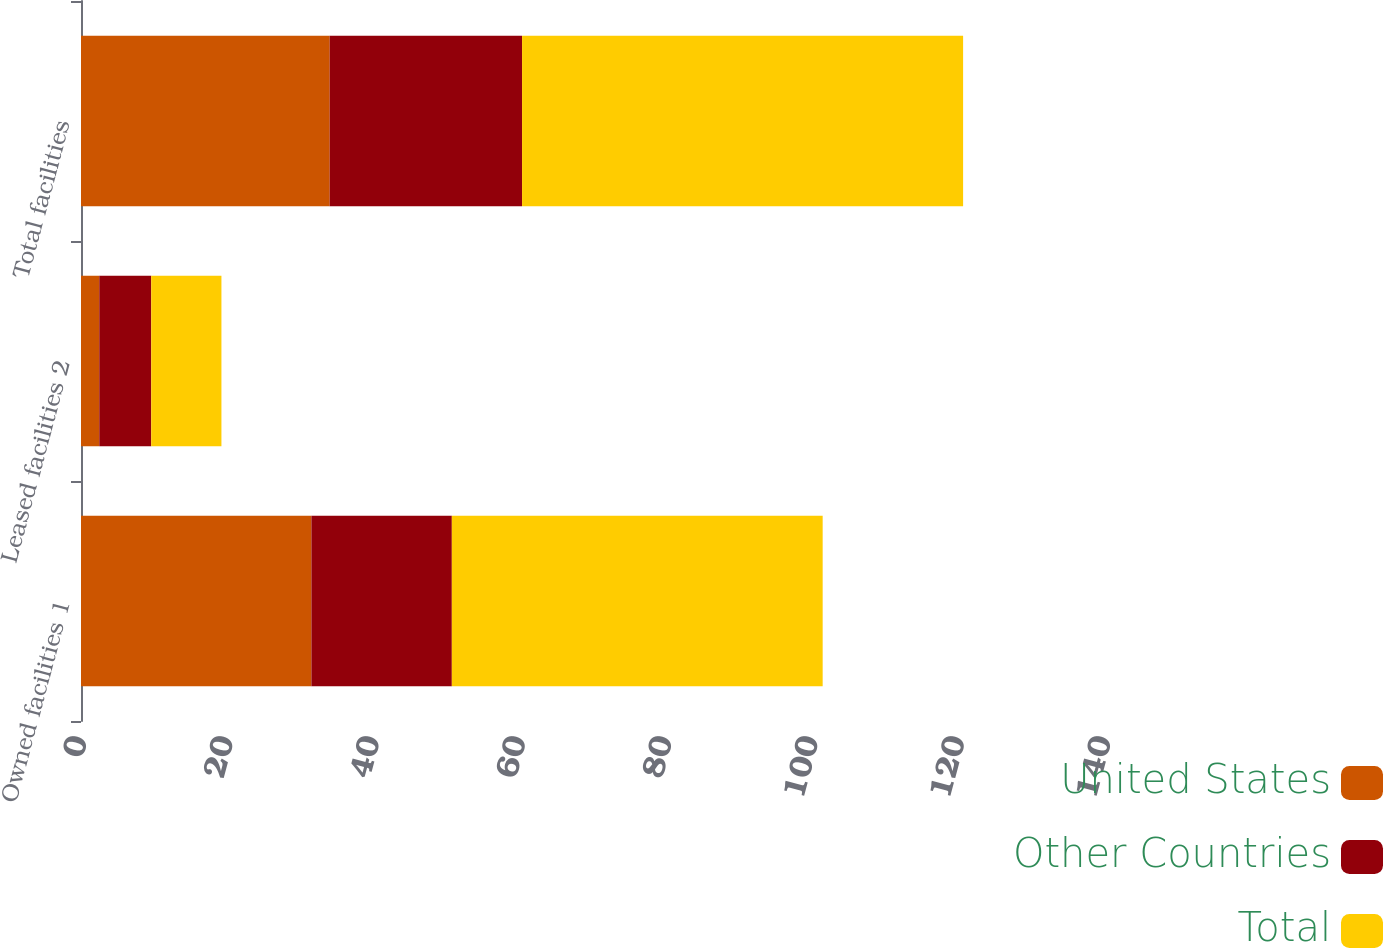Convert chart to OTSL. <chart><loc_0><loc_0><loc_500><loc_500><stacked_bar_chart><ecel><fcel>Owned facilities 1<fcel>Leased facilities 2<fcel>Total facilities<nl><fcel>United States<fcel>31.5<fcel>2.5<fcel>34<nl><fcel>Other Countries<fcel>19.2<fcel>7.1<fcel>26.3<nl><fcel>Total<fcel>50.7<fcel>9.6<fcel>60.3<nl></chart> 